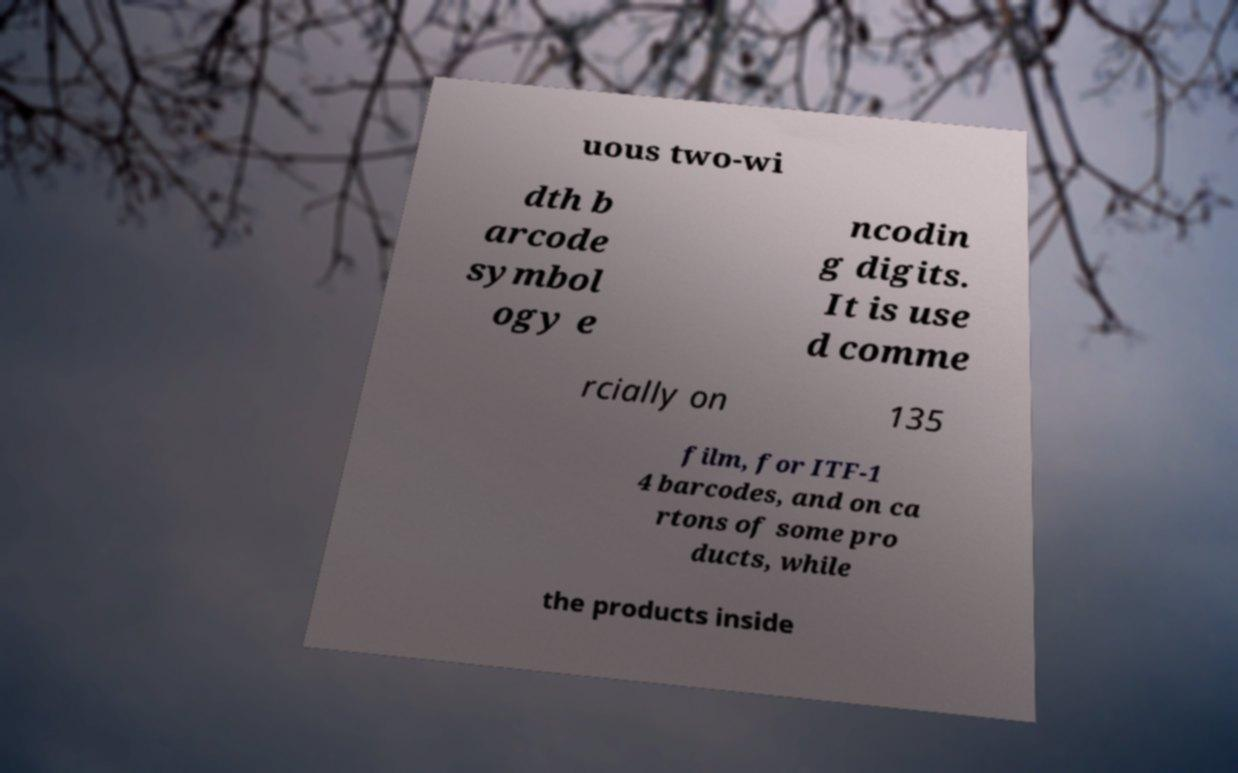Please read and relay the text visible in this image. What does it say? uous two-wi dth b arcode symbol ogy e ncodin g digits. It is use d comme rcially on 135 film, for ITF-1 4 barcodes, and on ca rtons of some pro ducts, while the products inside 